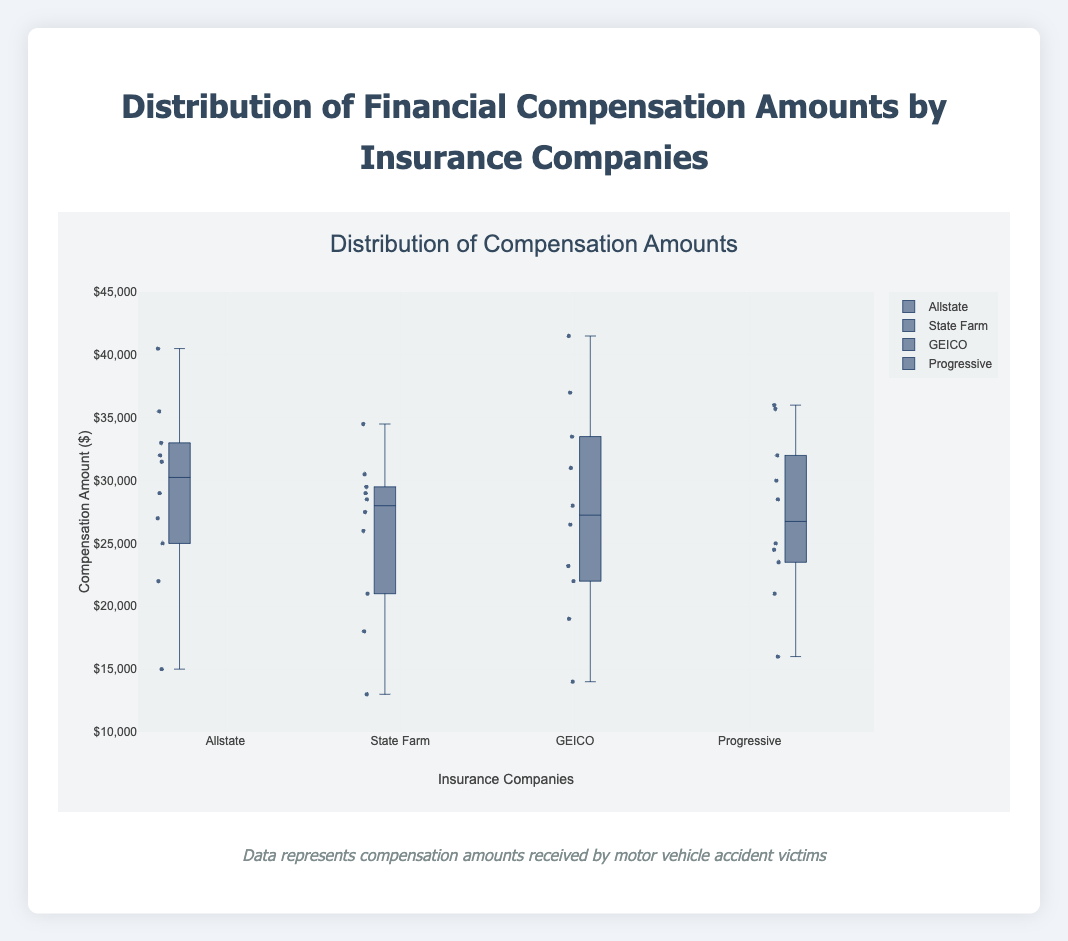What is the title of the plot? The title of the plot is displayed at the top center of the figure.
Answer: Distribution of Financial Compensation Amounts by Insurance Companies Which insurance company shows the highest median compensation amount? To find the highest median compensation amount, look for the line inside the box that represents the median. Compare these lines across all companies.
Answer: Allstate How many data points are plotted for GEICO? Each dot represents a single compensation amount. Count the number of dots in the GEICO section.
Answer: 10 Which insurance company has the smallest range between the minimum and maximum compensation amounts? The range is the distance between the top and bottom of the whiskers. Locate the shortest whiskers among all companies.
Answer: State Farm What is the median compensation amount for Progressive? Locate the line inside the box for Progressive, which represents the median.
Answer: 28500 Which two companies have the most similar median compensation amounts? Compare the median lines of each company and identify the two closest in value.
Answer: Progressive and State Farm Which insurance company has the widest interquartile range (IQR)? The IQR is represented by the height of the box. Find the company with the tallest box.
Answer: GEICO What is the maximum compensation amount in the Liberty Mutual dataset? The maximum value is at the top of the whisker for Liberty Mutual.
Answer: 36500 Which insurance company has the lowest minimum compensation amount? The minimum value is at the bottom of the whisker for each company. Identify the lowest among all companies.
Answer: State Farm Compare the median compensation amounts for Allstate and GEICO. Which is higher and by how much? Observe the median lines of both Allstate and GEICO. Subtract the median of GEICO from the median of Allstate to find the difference.
Answer: Allstate, by 500 